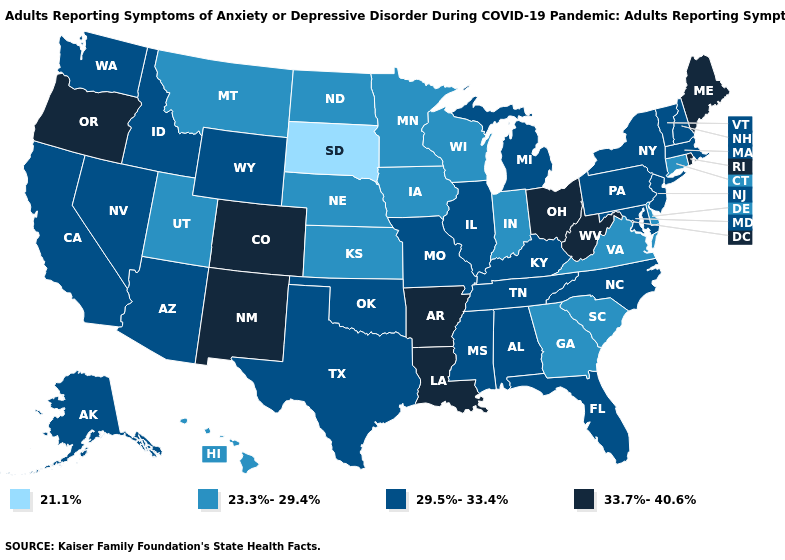How many symbols are there in the legend?
Keep it brief. 4. Which states hav the highest value in the West?
Quick response, please. Colorado, New Mexico, Oregon. Does West Virginia have a higher value than Maine?
Short answer required. No. What is the lowest value in states that border Maine?
Concise answer only. 29.5%-33.4%. Among the states that border Arkansas , does Louisiana have the lowest value?
Write a very short answer. No. What is the value of Iowa?
Concise answer only. 23.3%-29.4%. What is the lowest value in states that border Illinois?
Short answer required. 23.3%-29.4%. Which states have the lowest value in the USA?
Be succinct. South Dakota. Does New Mexico have the highest value in the West?
Concise answer only. Yes. Name the states that have a value in the range 29.5%-33.4%?
Quick response, please. Alabama, Alaska, Arizona, California, Florida, Idaho, Illinois, Kentucky, Maryland, Massachusetts, Michigan, Mississippi, Missouri, Nevada, New Hampshire, New Jersey, New York, North Carolina, Oklahoma, Pennsylvania, Tennessee, Texas, Vermont, Washington, Wyoming. Does Iowa have the highest value in the MidWest?
Short answer required. No. Name the states that have a value in the range 21.1%?
Keep it brief. South Dakota. What is the value of Michigan?
Be succinct. 29.5%-33.4%. Which states have the highest value in the USA?
Answer briefly. Arkansas, Colorado, Louisiana, Maine, New Mexico, Ohio, Oregon, Rhode Island, West Virginia. What is the lowest value in the USA?
Answer briefly. 21.1%. 